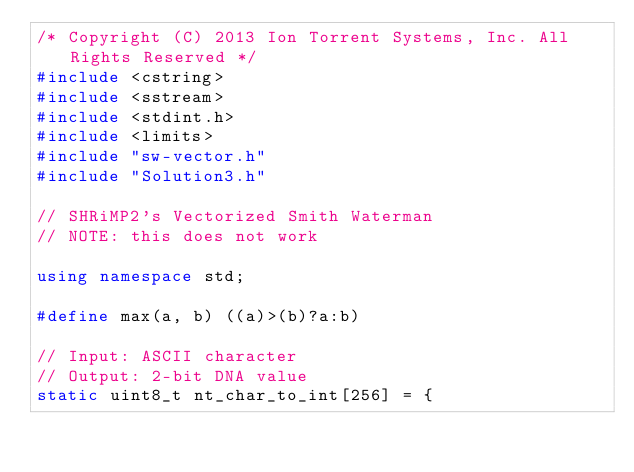Convert code to text. <code><loc_0><loc_0><loc_500><loc_500><_C++_>/* Copyright (C) 2013 Ion Torrent Systems, Inc. All Rights Reserved */
#include <cstring>
#include <sstream>
#include <stdint.h>
#include <limits>
#include "sw-vector.h"
#include "Solution3.h"

// SHRiMP2's Vectorized Smith Waterman
// NOTE: this does not work

using namespace std;

#define max(a, b) ((a)>(b)?a:b)

// Input: ASCII character
// Output: 2-bit DNA value
static uint8_t nt_char_to_int[256] = {</code> 